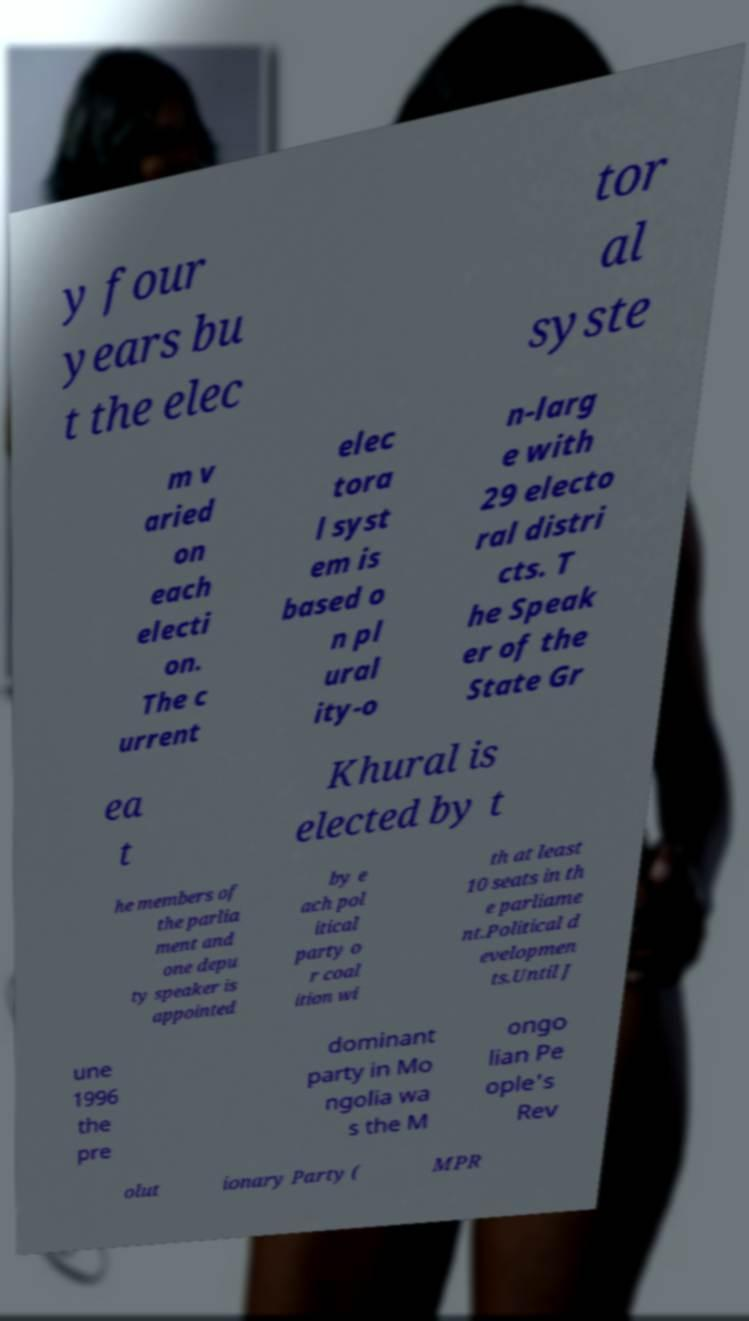Could you assist in decoding the text presented in this image and type it out clearly? y four years bu t the elec tor al syste m v aried on each electi on. The c urrent elec tora l syst em is based o n pl ural ity-o n-larg e with 29 electo ral distri cts. T he Speak er of the State Gr ea t Khural is elected by t he members of the parlia ment and one depu ty speaker is appointed by e ach pol itical party o r coal ition wi th at least 10 seats in th e parliame nt.Political d evelopmen ts.Until J une 1996 the pre dominant party in Mo ngolia wa s the M ongo lian Pe ople's Rev olut ionary Party ( MPR 